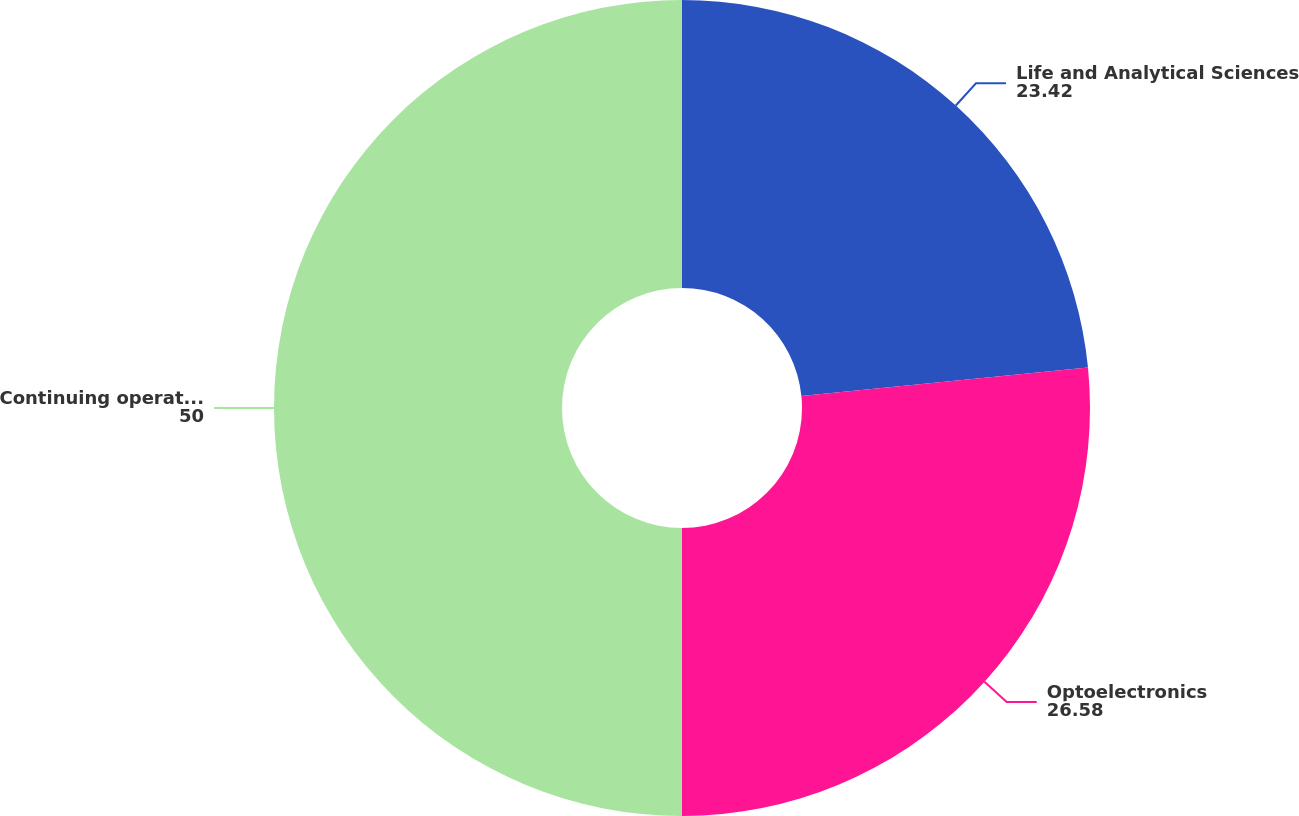<chart> <loc_0><loc_0><loc_500><loc_500><pie_chart><fcel>Life and Analytical Sciences<fcel>Optoelectronics<fcel>Continuing operations<nl><fcel>23.42%<fcel>26.58%<fcel>50.0%<nl></chart> 